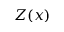<formula> <loc_0><loc_0><loc_500><loc_500>Z ( x )</formula> 